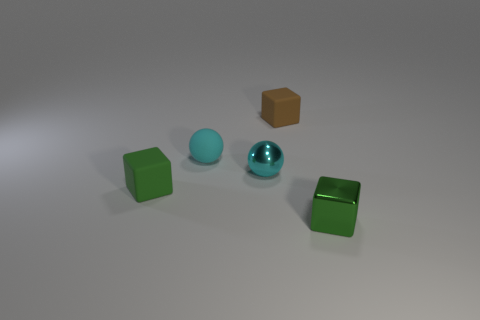Subtract all tiny green shiny cubes. How many cubes are left? 2 Subtract all brown spheres. How many green cubes are left? 2 Add 5 tiny yellow objects. How many objects exist? 10 Subtract all balls. How many objects are left? 3 Add 4 small matte blocks. How many small matte blocks exist? 6 Subtract 0 gray spheres. How many objects are left? 5 Subtract all red spheres. Subtract all green cubes. How many spheres are left? 2 Subtract all purple spheres. Subtract all tiny matte balls. How many objects are left? 4 Add 5 metallic spheres. How many metallic spheres are left? 6 